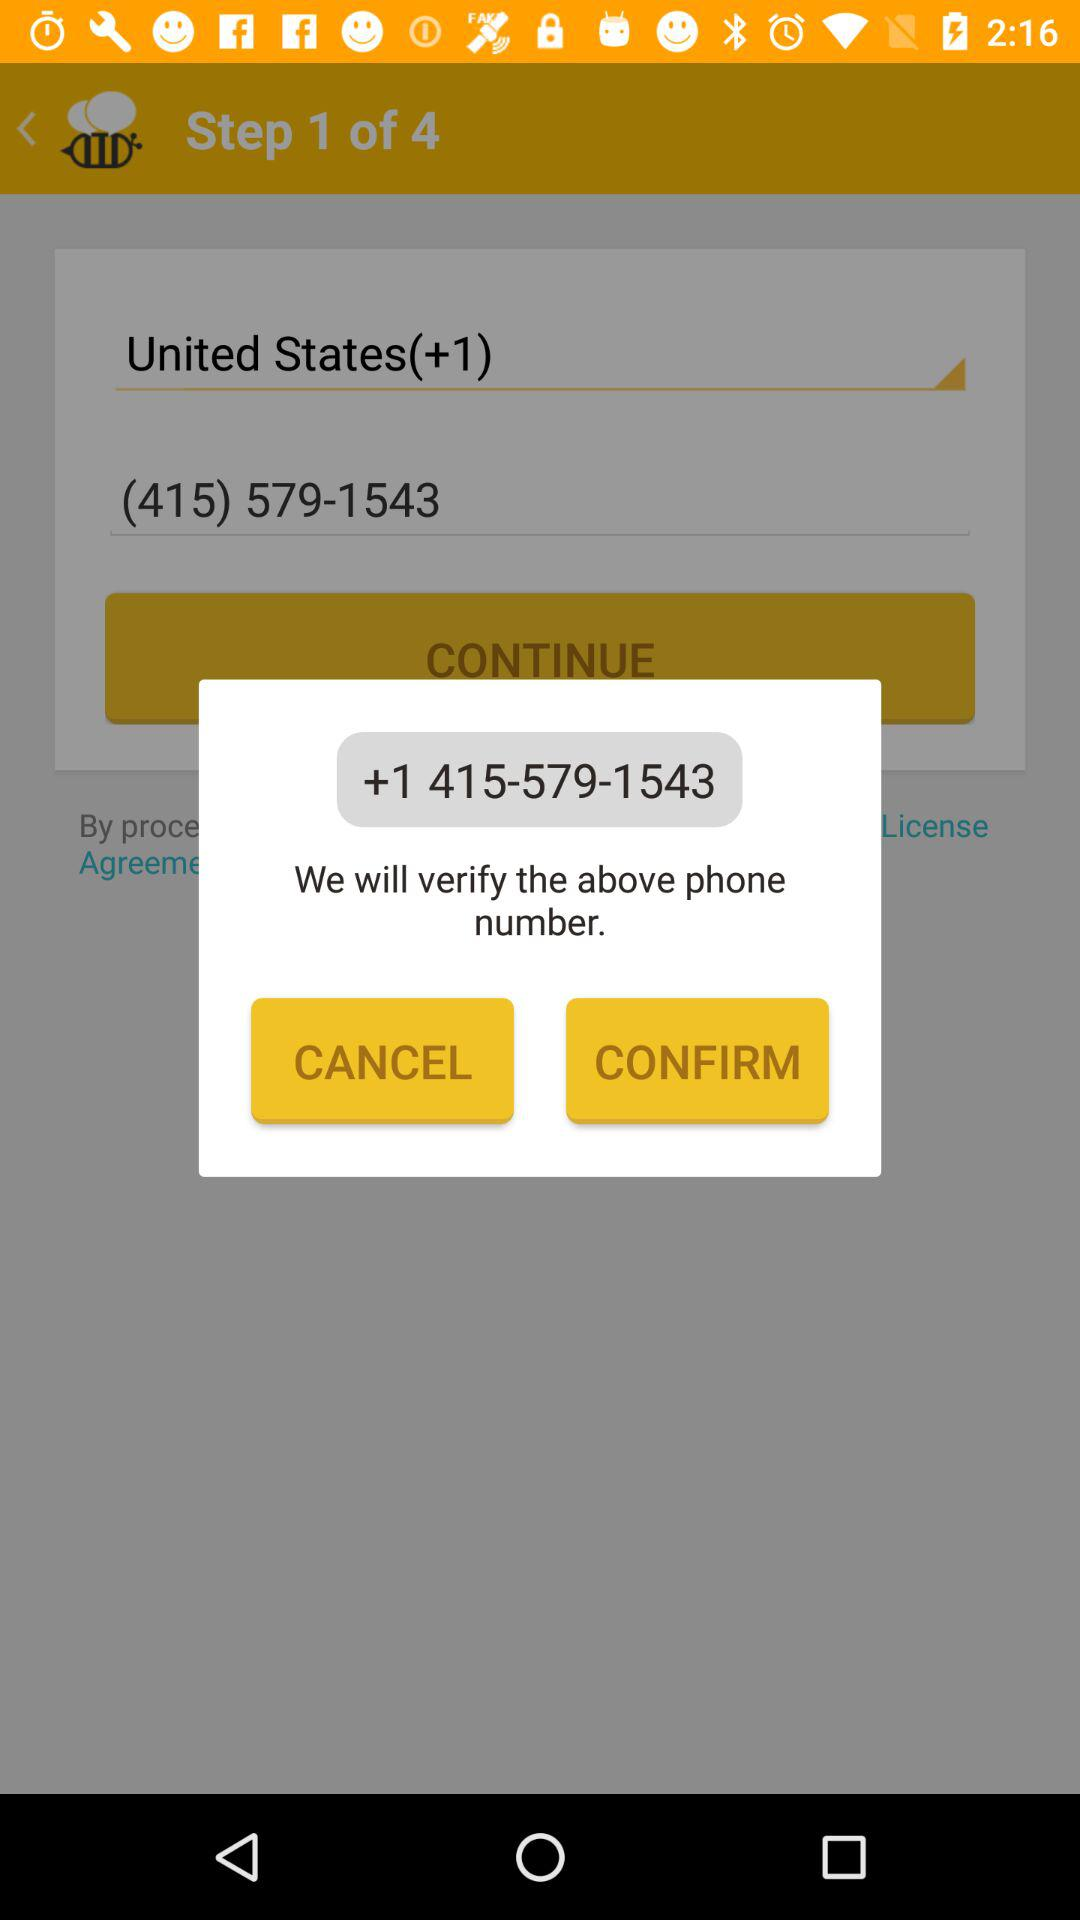What is the total number of steps? The total number of steps is 4. 